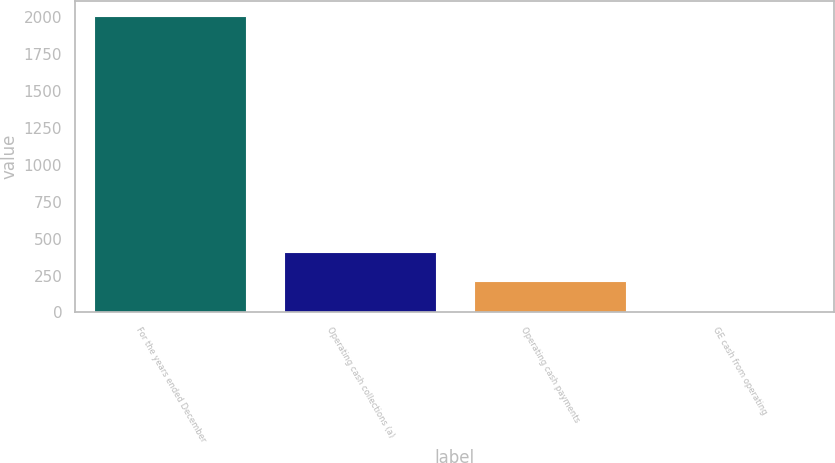Convert chart to OTSL. <chart><loc_0><loc_0><loc_500><loc_500><bar_chart><fcel>For the years ended December<fcel>Operating cash collections (a)<fcel>Operating cash payments<fcel>GE cash from operating<nl><fcel>2011<fcel>411.88<fcel>211.99<fcel>12.1<nl></chart> 